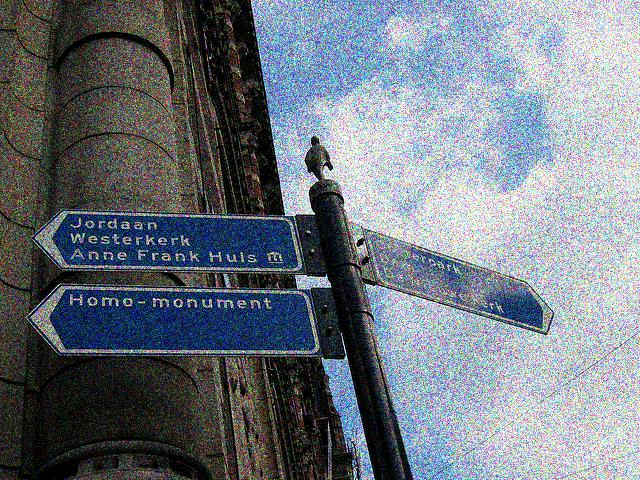What is the exposure like in the image? While the photograph appears to have an acceptable level of exposure overall, there is noticeable grain and pixelation which suggests it may have been taken with a high ISO setting or been edited to look this way. The areas in shadow, such as the building facade and the lower part of the pole, are somewhat underexposed, lacking detail in the darker regions. Therefore, the exposure could be classified as mostly accurate with a few underexposed areas that could have benefited from a bit more light. 